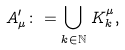Convert formula to latex. <formula><loc_0><loc_0><loc_500><loc_500>A _ { \mu } ^ { \prime } \colon = \bigcup _ { k \in \mathbb { N } } \, K ^ { \mu } _ { k } ,</formula> 